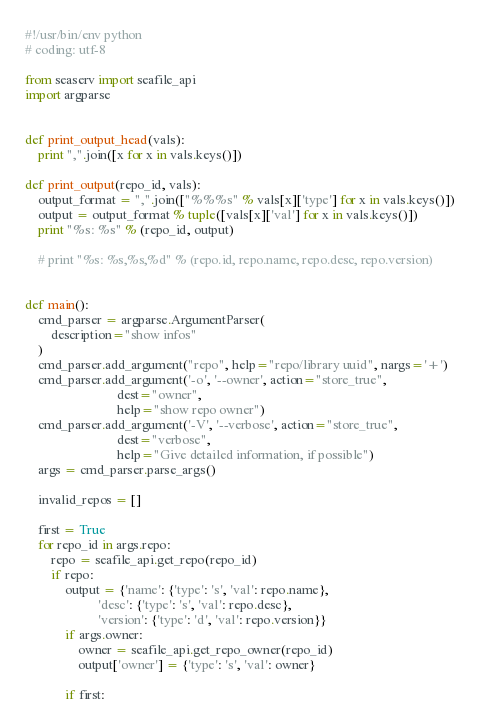Convert code to text. <code><loc_0><loc_0><loc_500><loc_500><_Python_>#!/usr/bin/env python
# coding: utf-8

from seaserv import seafile_api
import argparse


def print_output_head(vals):
    print ",".join([x for x in vals.keys()])

def print_output(repo_id, vals):
    output_format = ",".join(["%%%s" % vals[x]['type'] for x in vals.keys()])
    output = output_format % tuple([vals[x]['val'] for x in vals.keys()])
    print "%s: %s" % (repo_id, output)

    # print "%s: %s,%s,%d" % (repo.id, repo.name, repo.desc, repo.version)


def main():
    cmd_parser = argparse.ArgumentParser(
        description="show infos"
    )
    cmd_parser.add_argument("repo", help="repo/library uuid", nargs='+')
    cmd_parser.add_argument('-o', '--owner', action="store_true",
                            dest="owner",
                            help="show repo owner")
    cmd_parser.add_argument('-V', '--verbose', action="store_true",
                            dest="verbose",
                            help="Give detailed information, if possible")
    args = cmd_parser.parse_args()

    invalid_repos = []

    first = True
    for repo_id in args.repo:
        repo = seafile_api.get_repo(repo_id)
        if repo:
            output = {'name': {'type': 's', 'val': repo.name},
                      'desc': {'type': 's', 'val': repo.desc},
                      'version': {'type': 'd', 'val': repo.version}}
            if args.owner:
                owner = seafile_api.get_repo_owner(repo_id)
                output['owner'] = {'type': 's', 'val': owner}

            if first:</code> 